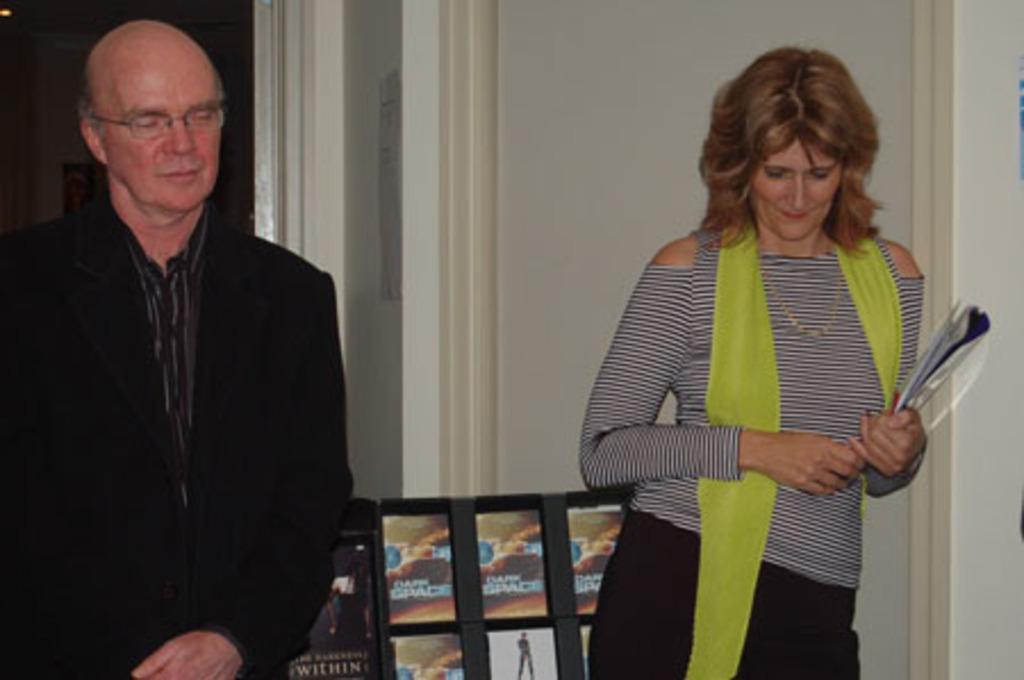Could you give a brief overview of what you see in this image? On the left side of this image there is a man wearing a suit, standing and closing his eyes. On the right side there is a woman holding some papers in the hand, looking at the downwards, standing and leaning to the wall. At the bottom there are few posts on which I can see some text. In the background there is a wall. 